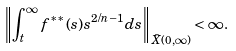<formula> <loc_0><loc_0><loc_500><loc_500>\left \| \int _ { t } ^ { \infty } f ^ { \ast \ast } ( s ) s ^ { 2 / n - 1 } d s \right \| _ { \bar { X } ( 0 , \infty ) } < \infty .</formula> 